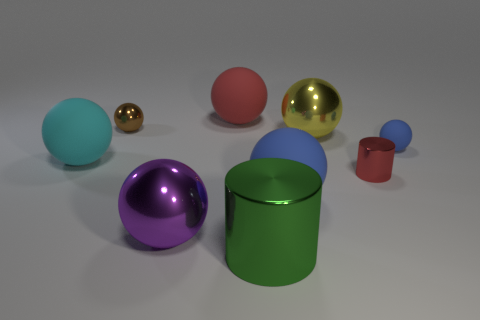Subtract all gray cylinders. How many blue spheres are left? 2 Subtract all large cyan matte spheres. How many spheres are left? 6 Subtract 2 balls. How many balls are left? 5 Subtract all blue spheres. How many spheres are left? 5 Add 1 big green metal things. How many objects exist? 10 Subtract all purple spheres. Subtract all brown cylinders. How many spheres are left? 6 Subtract all cylinders. How many objects are left? 7 Add 8 green objects. How many green objects exist? 9 Subtract 0 purple blocks. How many objects are left? 9 Subtract all yellow spheres. Subtract all large metallic spheres. How many objects are left? 6 